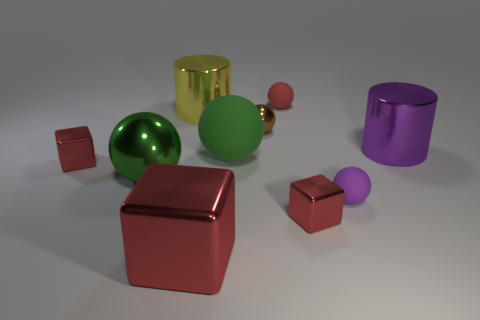Subtract all tiny purple balls. How many balls are left? 4 Subtract all brown spheres. How many spheres are left? 4 Subtract 2 balls. How many balls are left? 3 Subtract all cyan balls. Subtract all yellow cylinders. How many balls are left? 5 Subtract all cylinders. How many objects are left? 8 Subtract 0 blue cylinders. How many objects are left? 10 Subtract all big balls. Subtract all small shiny cubes. How many objects are left? 6 Add 3 red objects. How many red objects are left? 7 Add 7 tiny matte balls. How many tiny matte balls exist? 9 